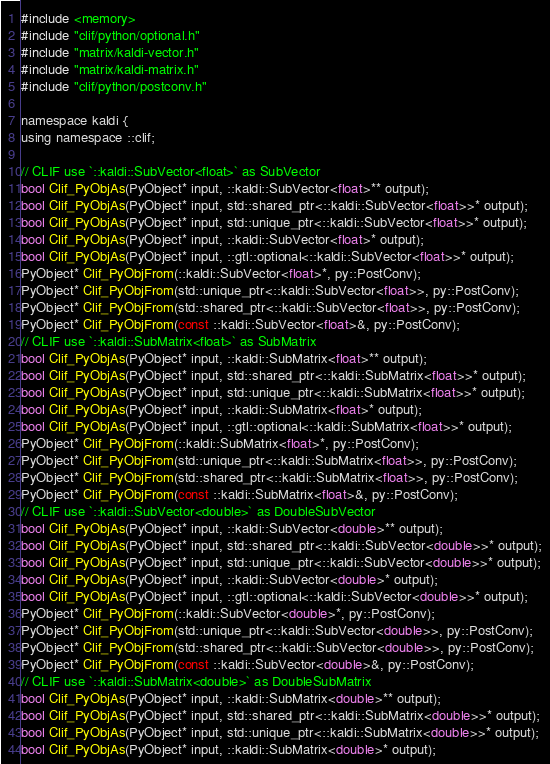<code> <loc_0><loc_0><loc_500><loc_500><_C_>
#include <memory>
#include "clif/python/optional.h"
#include "matrix/kaldi-vector.h"
#include "matrix/kaldi-matrix.h"
#include "clif/python/postconv.h"

namespace kaldi {
using namespace ::clif;

// CLIF use `::kaldi::SubVector<float>` as SubVector
bool Clif_PyObjAs(PyObject* input, ::kaldi::SubVector<float>** output);
bool Clif_PyObjAs(PyObject* input, std::shared_ptr<::kaldi::SubVector<float>>* output);
bool Clif_PyObjAs(PyObject* input, std::unique_ptr<::kaldi::SubVector<float>>* output);
bool Clif_PyObjAs(PyObject* input, ::kaldi::SubVector<float>* output);
bool Clif_PyObjAs(PyObject* input, ::gtl::optional<::kaldi::SubVector<float>>* output);
PyObject* Clif_PyObjFrom(::kaldi::SubVector<float>*, py::PostConv);
PyObject* Clif_PyObjFrom(std::unique_ptr<::kaldi::SubVector<float>>, py::PostConv);
PyObject* Clif_PyObjFrom(std::shared_ptr<::kaldi::SubVector<float>>, py::PostConv);
PyObject* Clif_PyObjFrom(const ::kaldi::SubVector<float>&, py::PostConv);
// CLIF use `::kaldi::SubMatrix<float>` as SubMatrix
bool Clif_PyObjAs(PyObject* input, ::kaldi::SubMatrix<float>** output);
bool Clif_PyObjAs(PyObject* input, std::shared_ptr<::kaldi::SubMatrix<float>>* output);
bool Clif_PyObjAs(PyObject* input, std::unique_ptr<::kaldi::SubMatrix<float>>* output);
bool Clif_PyObjAs(PyObject* input, ::kaldi::SubMatrix<float>* output);
bool Clif_PyObjAs(PyObject* input, ::gtl::optional<::kaldi::SubMatrix<float>>* output);
PyObject* Clif_PyObjFrom(::kaldi::SubMatrix<float>*, py::PostConv);
PyObject* Clif_PyObjFrom(std::unique_ptr<::kaldi::SubMatrix<float>>, py::PostConv);
PyObject* Clif_PyObjFrom(std::shared_ptr<::kaldi::SubMatrix<float>>, py::PostConv);
PyObject* Clif_PyObjFrom(const ::kaldi::SubMatrix<float>&, py::PostConv);
// CLIF use `::kaldi::SubVector<double>` as DoubleSubVector
bool Clif_PyObjAs(PyObject* input, ::kaldi::SubVector<double>** output);
bool Clif_PyObjAs(PyObject* input, std::shared_ptr<::kaldi::SubVector<double>>* output);
bool Clif_PyObjAs(PyObject* input, std::unique_ptr<::kaldi::SubVector<double>>* output);
bool Clif_PyObjAs(PyObject* input, ::kaldi::SubVector<double>* output);
bool Clif_PyObjAs(PyObject* input, ::gtl::optional<::kaldi::SubVector<double>>* output);
PyObject* Clif_PyObjFrom(::kaldi::SubVector<double>*, py::PostConv);
PyObject* Clif_PyObjFrom(std::unique_ptr<::kaldi::SubVector<double>>, py::PostConv);
PyObject* Clif_PyObjFrom(std::shared_ptr<::kaldi::SubVector<double>>, py::PostConv);
PyObject* Clif_PyObjFrom(const ::kaldi::SubVector<double>&, py::PostConv);
// CLIF use `::kaldi::SubMatrix<double>` as DoubleSubMatrix
bool Clif_PyObjAs(PyObject* input, ::kaldi::SubMatrix<double>** output);
bool Clif_PyObjAs(PyObject* input, std::shared_ptr<::kaldi::SubMatrix<double>>* output);
bool Clif_PyObjAs(PyObject* input, std::unique_ptr<::kaldi::SubMatrix<double>>* output);
bool Clif_PyObjAs(PyObject* input, ::kaldi::SubMatrix<double>* output);</code> 